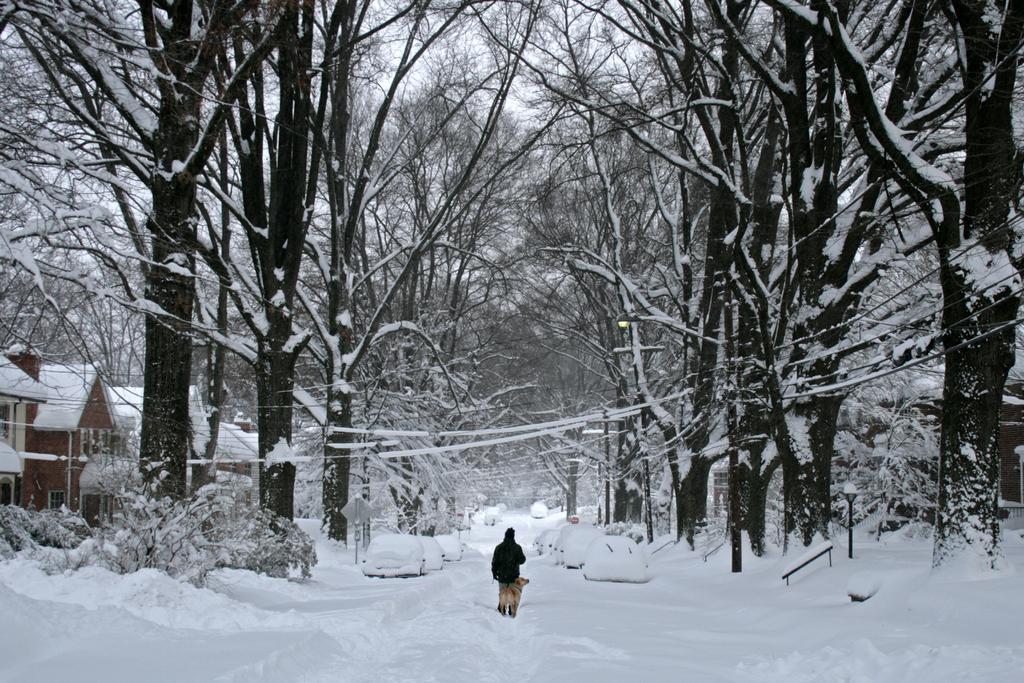How would you summarize this image in a sentence or two? There is a road which is completely covered with snow. On the side of the road there are some vehicles parked which are completely covered with snow. On this road in the snow, there is a man and dog who are walking. To the side of this road there are some trees and houses. There are some big trees here. We can observe some wires too, communication lines or electricity supply lines. There are some street lights. In the background we can observe sky. 